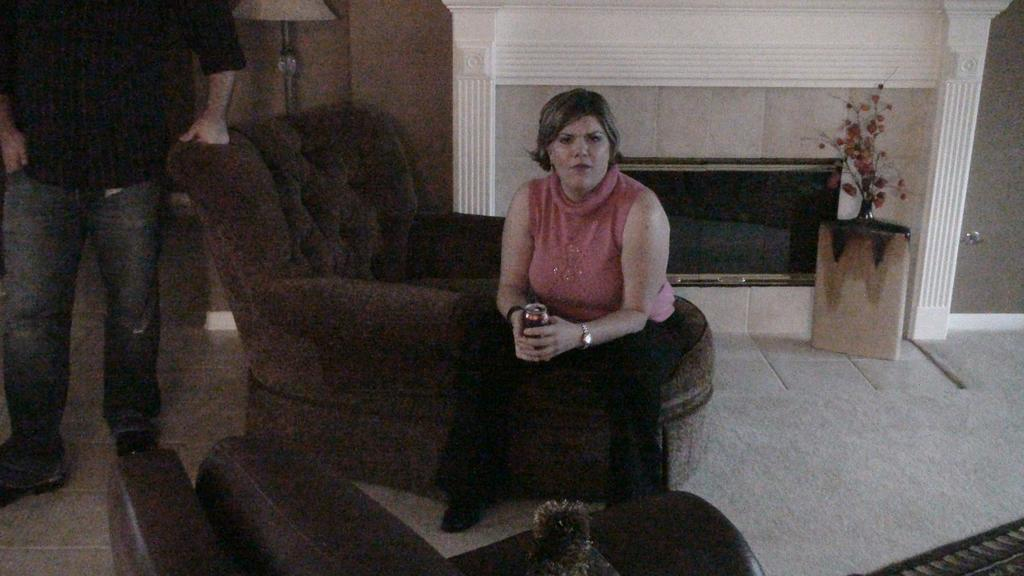What is the woman doing in the image? The woman is sitting on the couch in the image. What is the man doing in the image? The man is standing on the left side in the image. What can be seen in the background of the image? There is a wall and a plant in the backdrop of the image. What type of mice can be seen running around in the image? There are no mice present in the image. What is the aftermath of the bomb explosion in the image? There is no bomb explosion or any related aftermath in the image. 